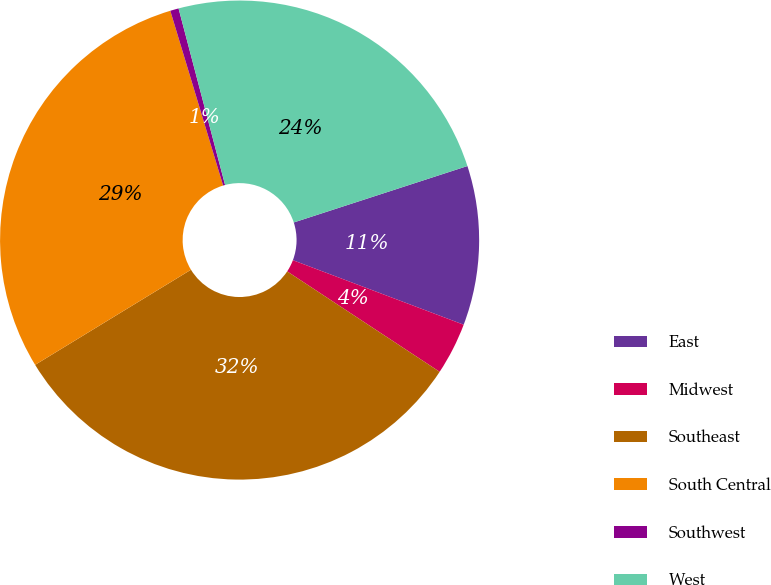Convert chart. <chart><loc_0><loc_0><loc_500><loc_500><pie_chart><fcel>East<fcel>Midwest<fcel>Southeast<fcel>South Central<fcel>Southwest<fcel>West<nl><fcel>10.75%<fcel>3.52%<fcel>32.01%<fcel>29.05%<fcel>0.57%<fcel>24.1%<nl></chart> 